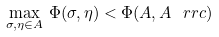<formula> <loc_0><loc_0><loc_500><loc_500>\max _ { \sigma , \eta \in A } \, \Phi ( \sigma , \eta ) < \Phi ( A , A ^ { \ } r r { c } )</formula> 